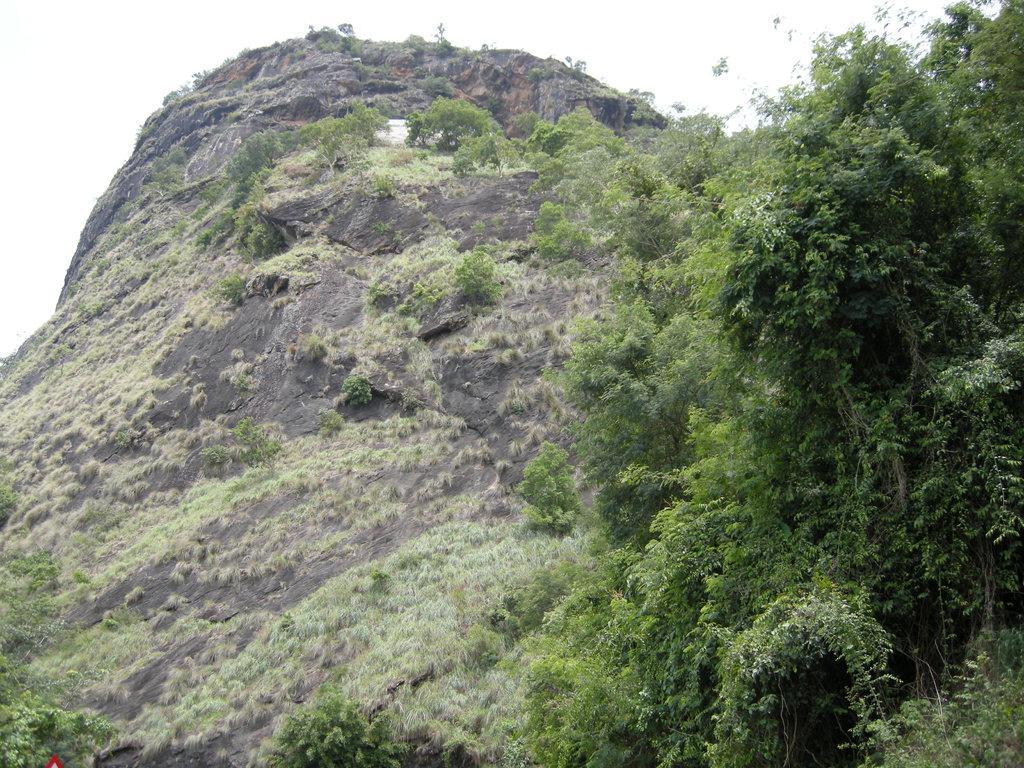Describe this image in one or two sentences. In this picture I can see a hill with some trees. 